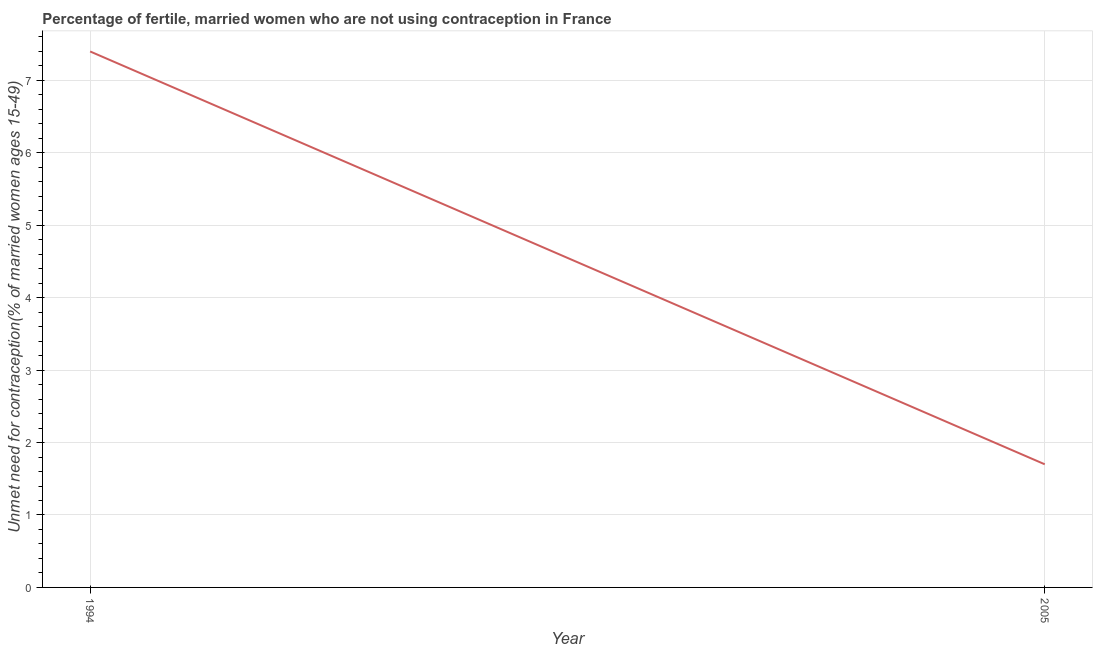Across all years, what is the maximum number of married women who are not using contraception?
Offer a very short reply. 7.4. What is the sum of the number of married women who are not using contraception?
Offer a terse response. 9.1. What is the difference between the number of married women who are not using contraception in 1994 and 2005?
Offer a very short reply. 5.7. What is the average number of married women who are not using contraception per year?
Your answer should be compact. 4.55. What is the median number of married women who are not using contraception?
Your answer should be compact. 4.55. In how many years, is the number of married women who are not using contraception greater than 2.4 %?
Give a very brief answer. 1. What is the ratio of the number of married women who are not using contraception in 1994 to that in 2005?
Provide a short and direct response. 4.35. In how many years, is the number of married women who are not using contraception greater than the average number of married women who are not using contraception taken over all years?
Provide a succinct answer. 1. What is the difference between two consecutive major ticks on the Y-axis?
Give a very brief answer. 1. Are the values on the major ticks of Y-axis written in scientific E-notation?
Provide a short and direct response. No. Does the graph contain grids?
Ensure brevity in your answer.  Yes. What is the title of the graph?
Provide a short and direct response. Percentage of fertile, married women who are not using contraception in France. What is the label or title of the Y-axis?
Provide a succinct answer.  Unmet need for contraception(% of married women ages 15-49). What is the difference between the  Unmet need for contraception(% of married women ages 15-49) in 1994 and 2005?
Provide a succinct answer. 5.7. What is the ratio of the  Unmet need for contraception(% of married women ages 15-49) in 1994 to that in 2005?
Provide a short and direct response. 4.35. 